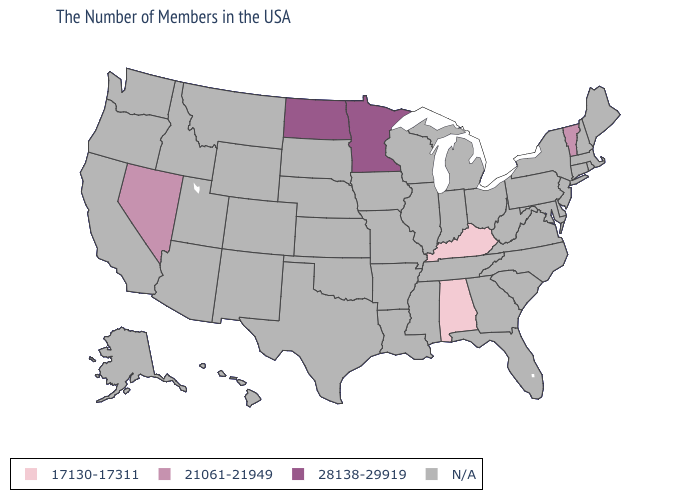Does Vermont have the lowest value in the USA?
Short answer required. No. Name the states that have a value in the range 17130-17311?
Be succinct. Kentucky, Alabama. What is the value of Louisiana?
Concise answer only. N/A. Name the states that have a value in the range 28138-29919?
Give a very brief answer. Minnesota, North Dakota. What is the value of North Carolina?
Be succinct. N/A. Which states hav the highest value in the South?
Keep it brief. Kentucky, Alabama. Does the map have missing data?
Give a very brief answer. Yes. What is the value of Maryland?
Quick response, please. N/A. Is the legend a continuous bar?
Quick response, please. No. Name the states that have a value in the range N/A?
Keep it brief. Maine, Massachusetts, Rhode Island, New Hampshire, Connecticut, New York, New Jersey, Delaware, Maryland, Pennsylvania, Virginia, North Carolina, South Carolina, West Virginia, Ohio, Florida, Georgia, Michigan, Indiana, Tennessee, Wisconsin, Illinois, Mississippi, Louisiana, Missouri, Arkansas, Iowa, Kansas, Nebraska, Oklahoma, Texas, South Dakota, Wyoming, Colorado, New Mexico, Utah, Montana, Arizona, Idaho, California, Washington, Oregon, Alaska, Hawaii. What is the value of Arizona?
Quick response, please. N/A. 